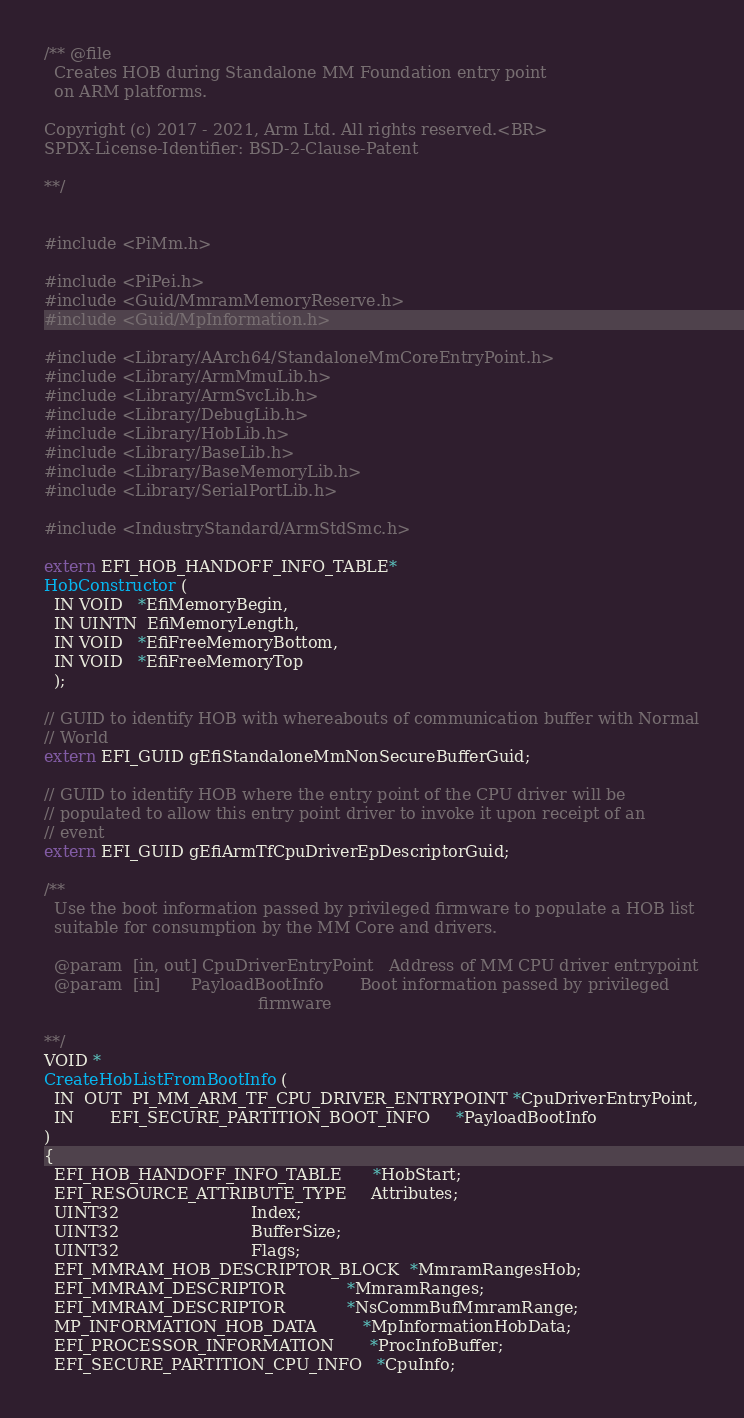Convert code to text. <code><loc_0><loc_0><loc_500><loc_500><_C_>/** @file
  Creates HOB during Standalone MM Foundation entry point
  on ARM platforms.

Copyright (c) 2017 - 2021, Arm Ltd. All rights reserved.<BR>
SPDX-License-Identifier: BSD-2-Clause-Patent

**/


#include <PiMm.h>

#include <PiPei.h>
#include <Guid/MmramMemoryReserve.h>
#include <Guid/MpInformation.h>

#include <Library/AArch64/StandaloneMmCoreEntryPoint.h>
#include <Library/ArmMmuLib.h>
#include <Library/ArmSvcLib.h>
#include <Library/DebugLib.h>
#include <Library/HobLib.h>
#include <Library/BaseLib.h>
#include <Library/BaseMemoryLib.h>
#include <Library/SerialPortLib.h>

#include <IndustryStandard/ArmStdSmc.h>

extern EFI_HOB_HANDOFF_INFO_TABLE*
HobConstructor (
  IN VOID   *EfiMemoryBegin,
  IN UINTN  EfiMemoryLength,
  IN VOID   *EfiFreeMemoryBottom,
  IN VOID   *EfiFreeMemoryTop
  );

// GUID to identify HOB with whereabouts of communication buffer with Normal
// World
extern EFI_GUID gEfiStandaloneMmNonSecureBufferGuid;

// GUID to identify HOB where the entry point of the CPU driver will be
// populated to allow this entry point driver to invoke it upon receipt of an
// event
extern EFI_GUID gEfiArmTfCpuDriverEpDescriptorGuid;

/**
  Use the boot information passed by privileged firmware to populate a HOB list
  suitable for consumption by the MM Core and drivers.

  @param  [in, out] CpuDriverEntryPoint   Address of MM CPU driver entrypoint
  @param  [in]      PayloadBootInfo       Boot information passed by privileged
                                          firmware

**/
VOID *
CreateHobListFromBootInfo (
  IN  OUT  PI_MM_ARM_TF_CPU_DRIVER_ENTRYPOINT *CpuDriverEntryPoint,
  IN       EFI_SECURE_PARTITION_BOOT_INFO     *PayloadBootInfo
)
{
  EFI_HOB_HANDOFF_INFO_TABLE      *HobStart;
  EFI_RESOURCE_ATTRIBUTE_TYPE     Attributes;
  UINT32                          Index;
  UINT32                          BufferSize;
  UINT32                          Flags;
  EFI_MMRAM_HOB_DESCRIPTOR_BLOCK  *MmramRangesHob;
  EFI_MMRAM_DESCRIPTOR            *MmramRanges;
  EFI_MMRAM_DESCRIPTOR            *NsCommBufMmramRange;
  MP_INFORMATION_HOB_DATA         *MpInformationHobData;
  EFI_PROCESSOR_INFORMATION       *ProcInfoBuffer;
  EFI_SECURE_PARTITION_CPU_INFO   *CpuInfo;</code> 